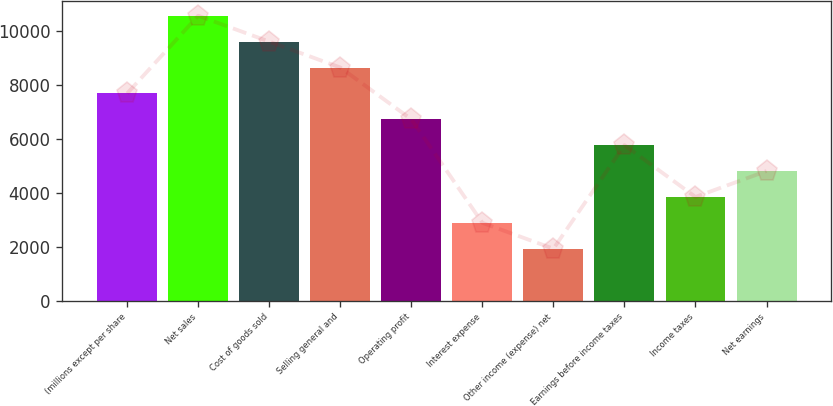Convert chart. <chart><loc_0><loc_0><loc_500><loc_500><bar_chart><fcel>(millions except per share<fcel>Net sales<fcel>Cost of goods sold<fcel>Selling general and<fcel>Operating profit<fcel>Interest expense<fcel>Other income (expense) net<fcel>Earnings before income taxes<fcel>Income taxes<fcel>Net earnings<nl><fcel>7691.58<fcel>10575.1<fcel>9613.94<fcel>8652.76<fcel>6730.4<fcel>2885.68<fcel>1924.5<fcel>5769.22<fcel>3846.86<fcel>4808.04<nl></chart> 